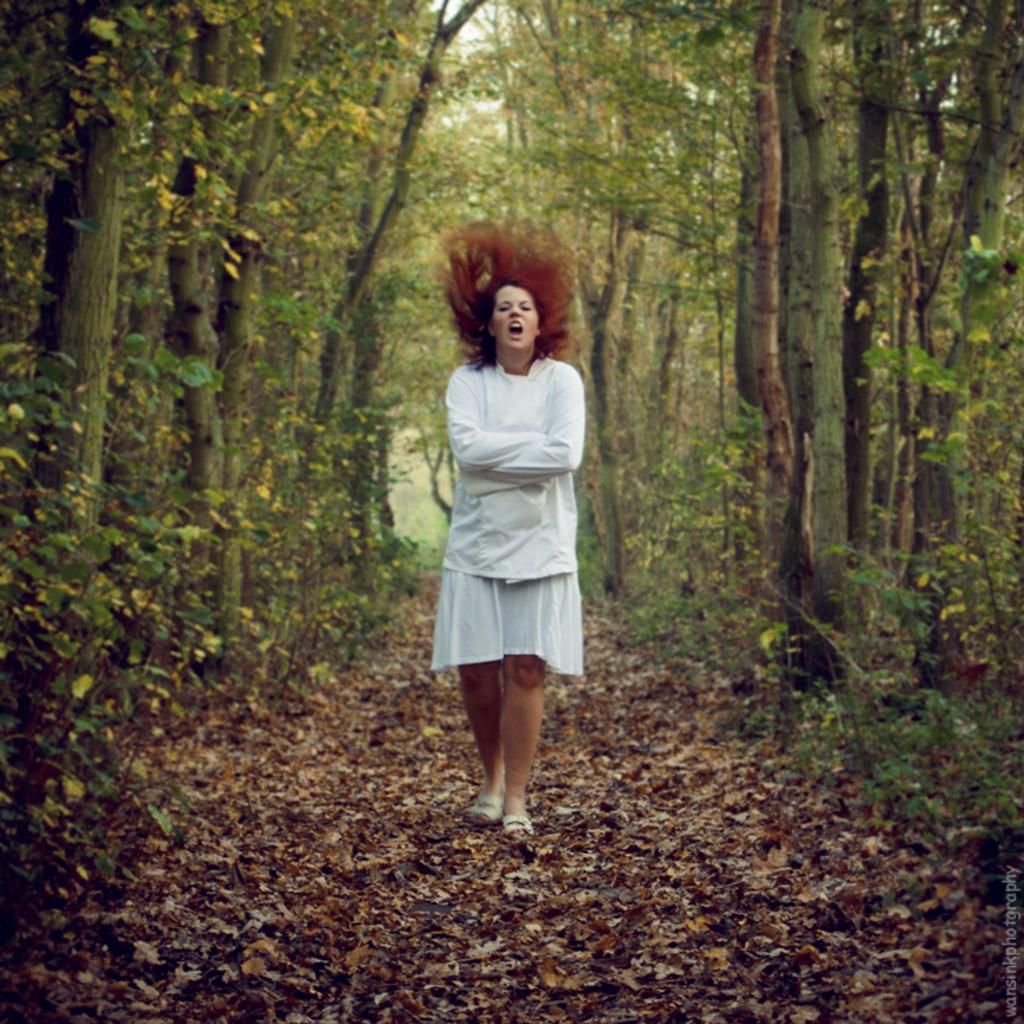What is the main action being performed by the person in the image? The person is walking in the image. What is the surface the person is walking on? The person is walking on dried leaves. What can be seen in the background of the image? There are trees in the background of the image. Where is the text located in the image? The text is on the right side of the image. How many cattle are grazing in the image? There are no cattle present in the image. What type of pets can be seen accompanying the person in the image? There are no pets visible in the image. 